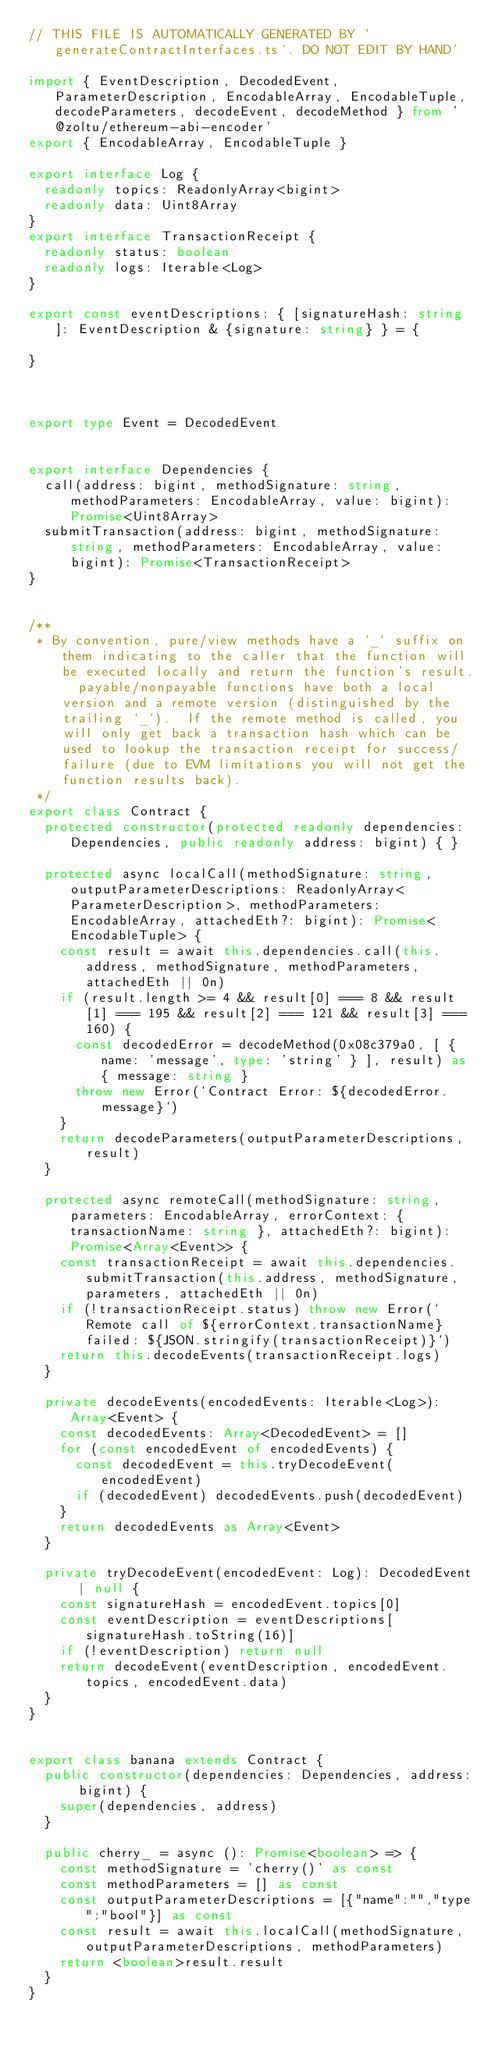Convert code to text. <code><loc_0><loc_0><loc_500><loc_500><_TypeScript_>// THIS FILE IS AUTOMATICALLY GENERATED BY `generateContractInterfaces.ts`. DO NOT EDIT BY HAND'

import { EventDescription, DecodedEvent, ParameterDescription, EncodableArray, EncodableTuple, decodeParameters, decodeEvent, decodeMethod } from '@zoltu/ethereum-abi-encoder'
export { EncodableArray, EncodableTuple }

export interface Log {
	readonly topics: ReadonlyArray<bigint>
	readonly data: Uint8Array
}
export interface TransactionReceipt {
	readonly status: boolean
	readonly logs: Iterable<Log>
}

export const eventDescriptions: { [signatureHash: string]: EventDescription & {signature: string} } = {

}



export type Event = DecodedEvent


export interface Dependencies {
	call(address: bigint, methodSignature: string, methodParameters: EncodableArray, value: bigint): Promise<Uint8Array>
	submitTransaction(address: bigint, methodSignature: string, methodParameters: EncodableArray, value: bigint): Promise<TransactionReceipt>
}


/**
 * By convention, pure/view methods have a `_` suffix on them indicating to the caller that the function will be executed locally and return the function's result.  payable/nonpayable functions have both a local version and a remote version (distinguished by the trailing `_`).  If the remote method is called, you will only get back a transaction hash which can be used to lookup the transaction receipt for success/failure (due to EVM limitations you will not get the function results back).
 */
export class Contract {
	protected constructor(protected readonly dependencies: Dependencies, public readonly address: bigint) { }

	protected async localCall(methodSignature: string, outputParameterDescriptions: ReadonlyArray<ParameterDescription>, methodParameters: EncodableArray, attachedEth?: bigint): Promise<EncodableTuple> {
		const result = await this.dependencies.call(this.address, methodSignature, methodParameters, attachedEth || 0n)
		if (result.length >= 4 && result[0] === 8 && result[1] === 195 && result[2] === 121 && result[3] === 160) {
			const decodedError = decodeMethod(0x08c379a0, [ { name: 'message', type: 'string' } ], result) as { message: string }
			throw new Error(`Contract Error: ${decodedError.message}`)
		}
		return decodeParameters(outputParameterDescriptions, result)
	}

	protected async remoteCall(methodSignature: string, parameters: EncodableArray, errorContext: { transactionName: string }, attachedEth?: bigint): Promise<Array<Event>> {
		const transactionReceipt = await this.dependencies.submitTransaction(this.address, methodSignature, parameters, attachedEth || 0n)
		if (!transactionReceipt.status) throw new Error(`Remote call of ${errorContext.transactionName} failed: ${JSON.stringify(transactionReceipt)}`)
		return this.decodeEvents(transactionReceipt.logs)
	}

	private decodeEvents(encodedEvents: Iterable<Log>): Array<Event> {
		const decodedEvents: Array<DecodedEvent> = []
		for (const encodedEvent of encodedEvents) {
			const decodedEvent = this.tryDecodeEvent(encodedEvent)
			if (decodedEvent) decodedEvents.push(decodedEvent)
		}
		return decodedEvents as Array<Event>
	}

	private tryDecodeEvent(encodedEvent: Log): DecodedEvent | null {
		const signatureHash = encodedEvent.topics[0]
		const eventDescription = eventDescriptions[signatureHash.toString(16)]
		if (!eventDescription) return null
		return decodeEvent(eventDescription, encodedEvent.topics, encodedEvent.data)
	}
}


export class banana extends Contract {
	public constructor(dependencies: Dependencies, address: bigint) {
		super(dependencies, address)
	}

	public cherry_ = async (): Promise<boolean> => {
		const methodSignature = 'cherry()' as const
		const methodParameters = [] as const
		const outputParameterDescriptions = [{"name":"","type":"bool"}] as const
		const result = await this.localCall(methodSignature, outputParameterDescriptions, methodParameters)
		return <boolean>result.result
	}
}
</code> 